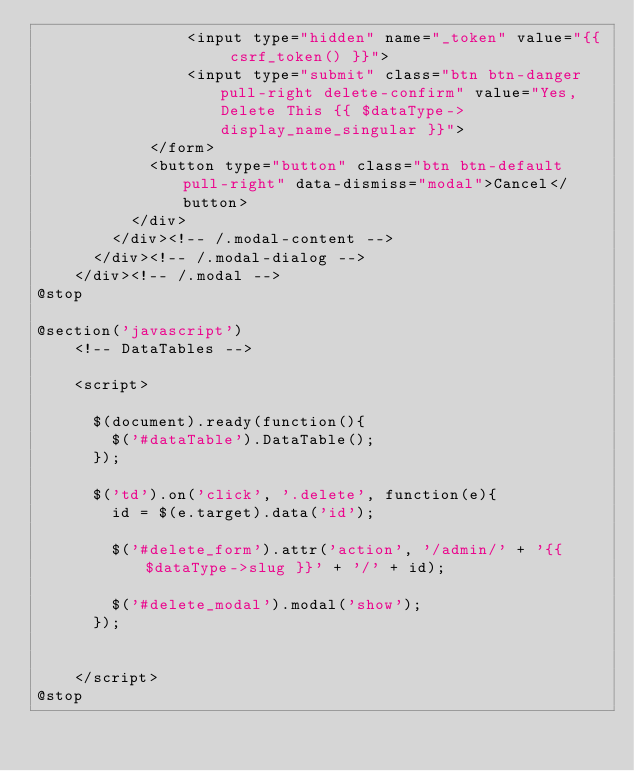Convert code to text. <code><loc_0><loc_0><loc_500><loc_500><_PHP_>            	<input type="hidden" name="_token" value="{{ csrf_token() }}">
            	<input type="submit" class="btn btn-danger pull-right delete-confirm" value="Yes, Delete This {{ $dataType->display_name_singular }}">
          	</form>
          	<button type="button" class="btn btn-default pull-right" data-dismiss="modal">Cancel</button>
          </div>
	    </div><!-- /.modal-content -->
	  </div><!-- /.modal-dialog -->
	</div><!-- /.modal --> 
@stop

@section('javascript')
	<!-- DataTables -->

    <script>

      $(document).ready(function(){
        $('#dataTable').DataTable();
      });

      $('td').on('click', '.delete', function(e){
      	id = $(e.target).data('id');
      
      	$('#delete_form').attr('action', '/admin/' + '{{ $dataType->slug }}' + '/' + id);

      	$('#delete_modal').modal('show');
      });

     
    </script>
@stop</code> 